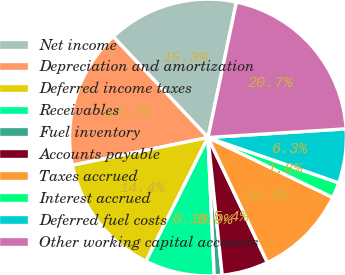Convert chart to OTSL. <chart><loc_0><loc_0><loc_500><loc_500><pie_chart><fcel>Net income<fcel>Depreciation and amortization<fcel>Deferred income taxes<fcel>Receivables<fcel>Fuel inventory<fcel>Accounts payable<fcel>Taxes accrued<fcel>Interest accrued<fcel>Deferred fuel costs<fcel>Other working capital accounts<nl><fcel>15.3%<fcel>16.2%<fcel>14.4%<fcel>8.11%<fcel>0.92%<fcel>5.42%<fcel>10.81%<fcel>1.82%<fcel>6.31%<fcel>20.7%<nl></chart> 